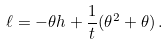<formula> <loc_0><loc_0><loc_500><loc_500>\ell = - \theta h + \frac { 1 } { t } ( \theta ^ { 2 } + \theta ) \, .</formula> 